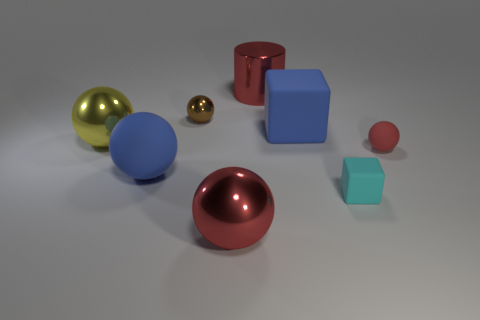Is there any pattern or organization to how the objects are arranged? No discernible pattern or organization is immediately apparent. The objects seem to be randomly placed with various sizes and distances from one another. Could you guess the material the objects are made of based on their appearance? The objects in the image appear to have a shiny, reflective surface, suggesting they could be made of metal or a similarly reflective material. 